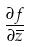<formula> <loc_0><loc_0><loc_500><loc_500>\frac { \partial f } { \partial \overline { z } }</formula> 